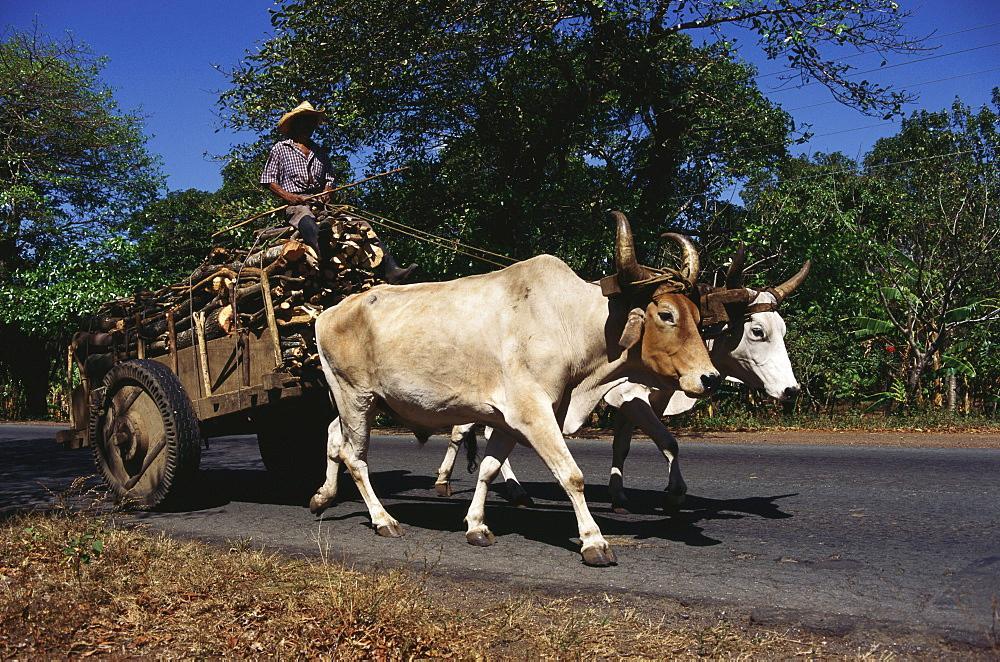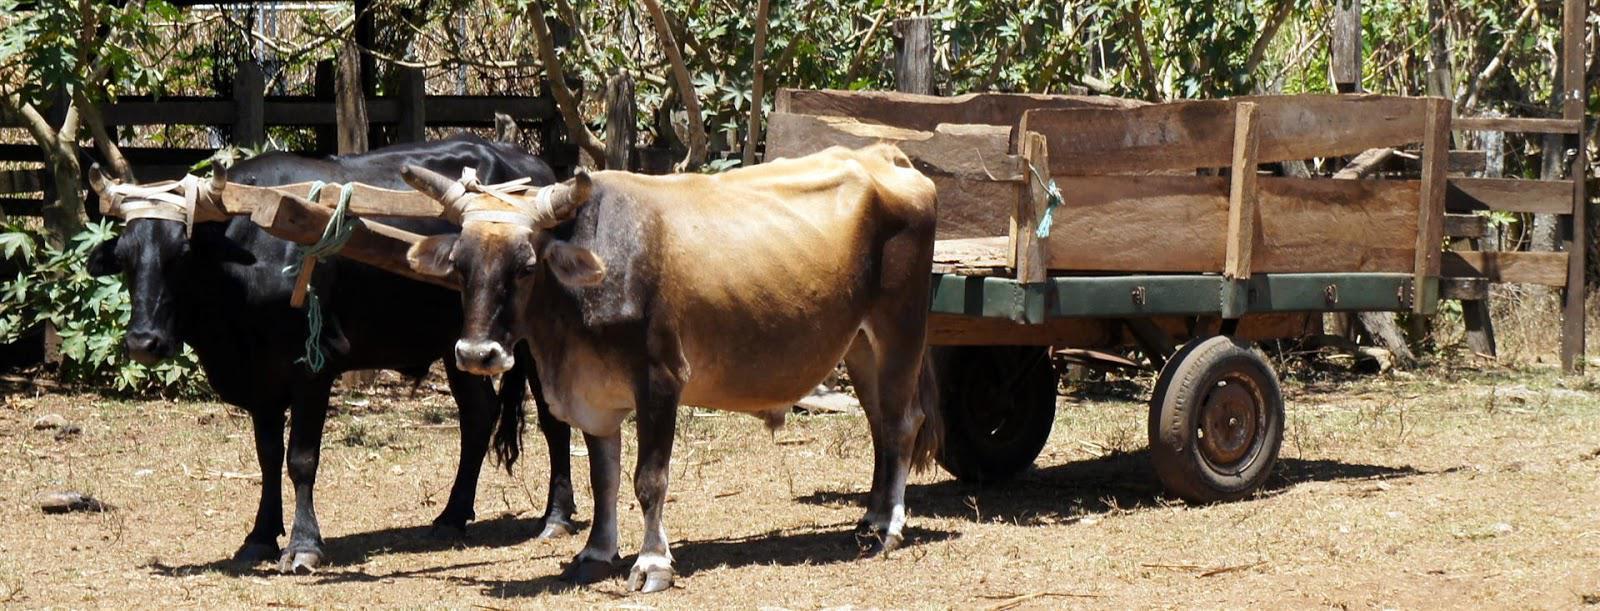The first image is the image on the left, the second image is the image on the right. Assess this claim about the two images: "All the cows in the image are attached to, and pulling, something behind them.". Correct or not? Answer yes or no. Yes. The first image is the image on the left, the second image is the image on the right. Considering the images on both sides, is "All of the animals are walking." valid? Answer yes or no. No. 